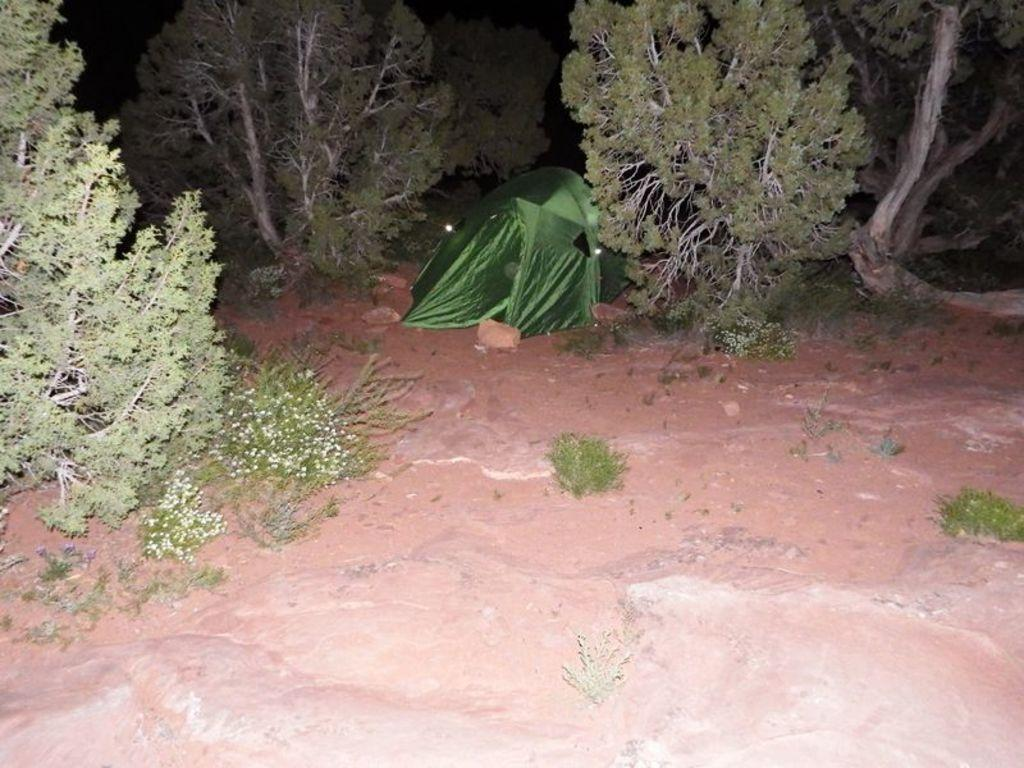What type of vegetation can be seen in the image? There are trees in the image. What type of shelter is present in the image? There is a green tent in the image. What material is visible in the image? There are bricks in the image. What is the average income of the people living in the green tent in the image? There is no information about the people living in the green tent or their income in the image. 